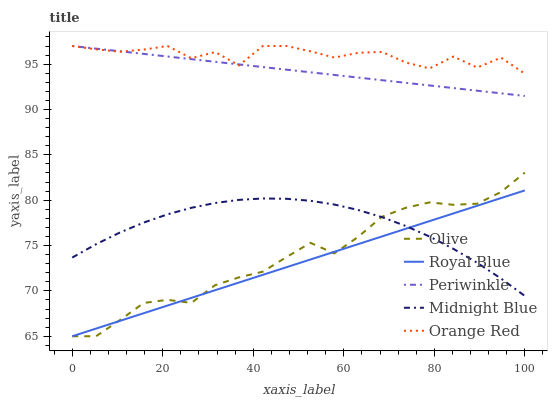Does Royal Blue have the minimum area under the curve?
Answer yes or no. Yes. Does Orange Red have the maximum area under the curve?
Answer yes or no. Yes. Does Periwinkle have the minimum area under the curve?
Answer yes or no. No. Does Periwinkle have the maximum area under the curve?
Answer yes or no. No. Is Periwinkle the smoothest?
Answer yes or no. Yes. Is Orange Red the roughest?
Answer yes or no. Yes. Is Royal Blue the smoothest?
Answer yes or no. No. Is Royal Blue the roughest?
Answer yes or no. No. Does Olive have the lowest value?
Answer yes or no. Yes. Does Periwinkle have the lowest value?
Answer yes or no. No. Does Orange Red have the highest value?
Answer yes or no. Yes. Does Royal Blue have the highest value?
Answer yes or no. No. Is Midnight Blue less than Orange Red?
Answer yes or no. Yes. Is Periwinkle greater than Royal Blue?
Answer yes or no. Yes. Does Royal Blue intersect Midnight Blue?
Answer yes or no. Yes. Is Royal Blue less than Midnight Blue?
Answer yes or no. No. Is Royal Blue greater than Midnight Blue?
Answer yes or no. No. Does Midnight Blue intersect Orange Red?
Answer yes or no. No. 